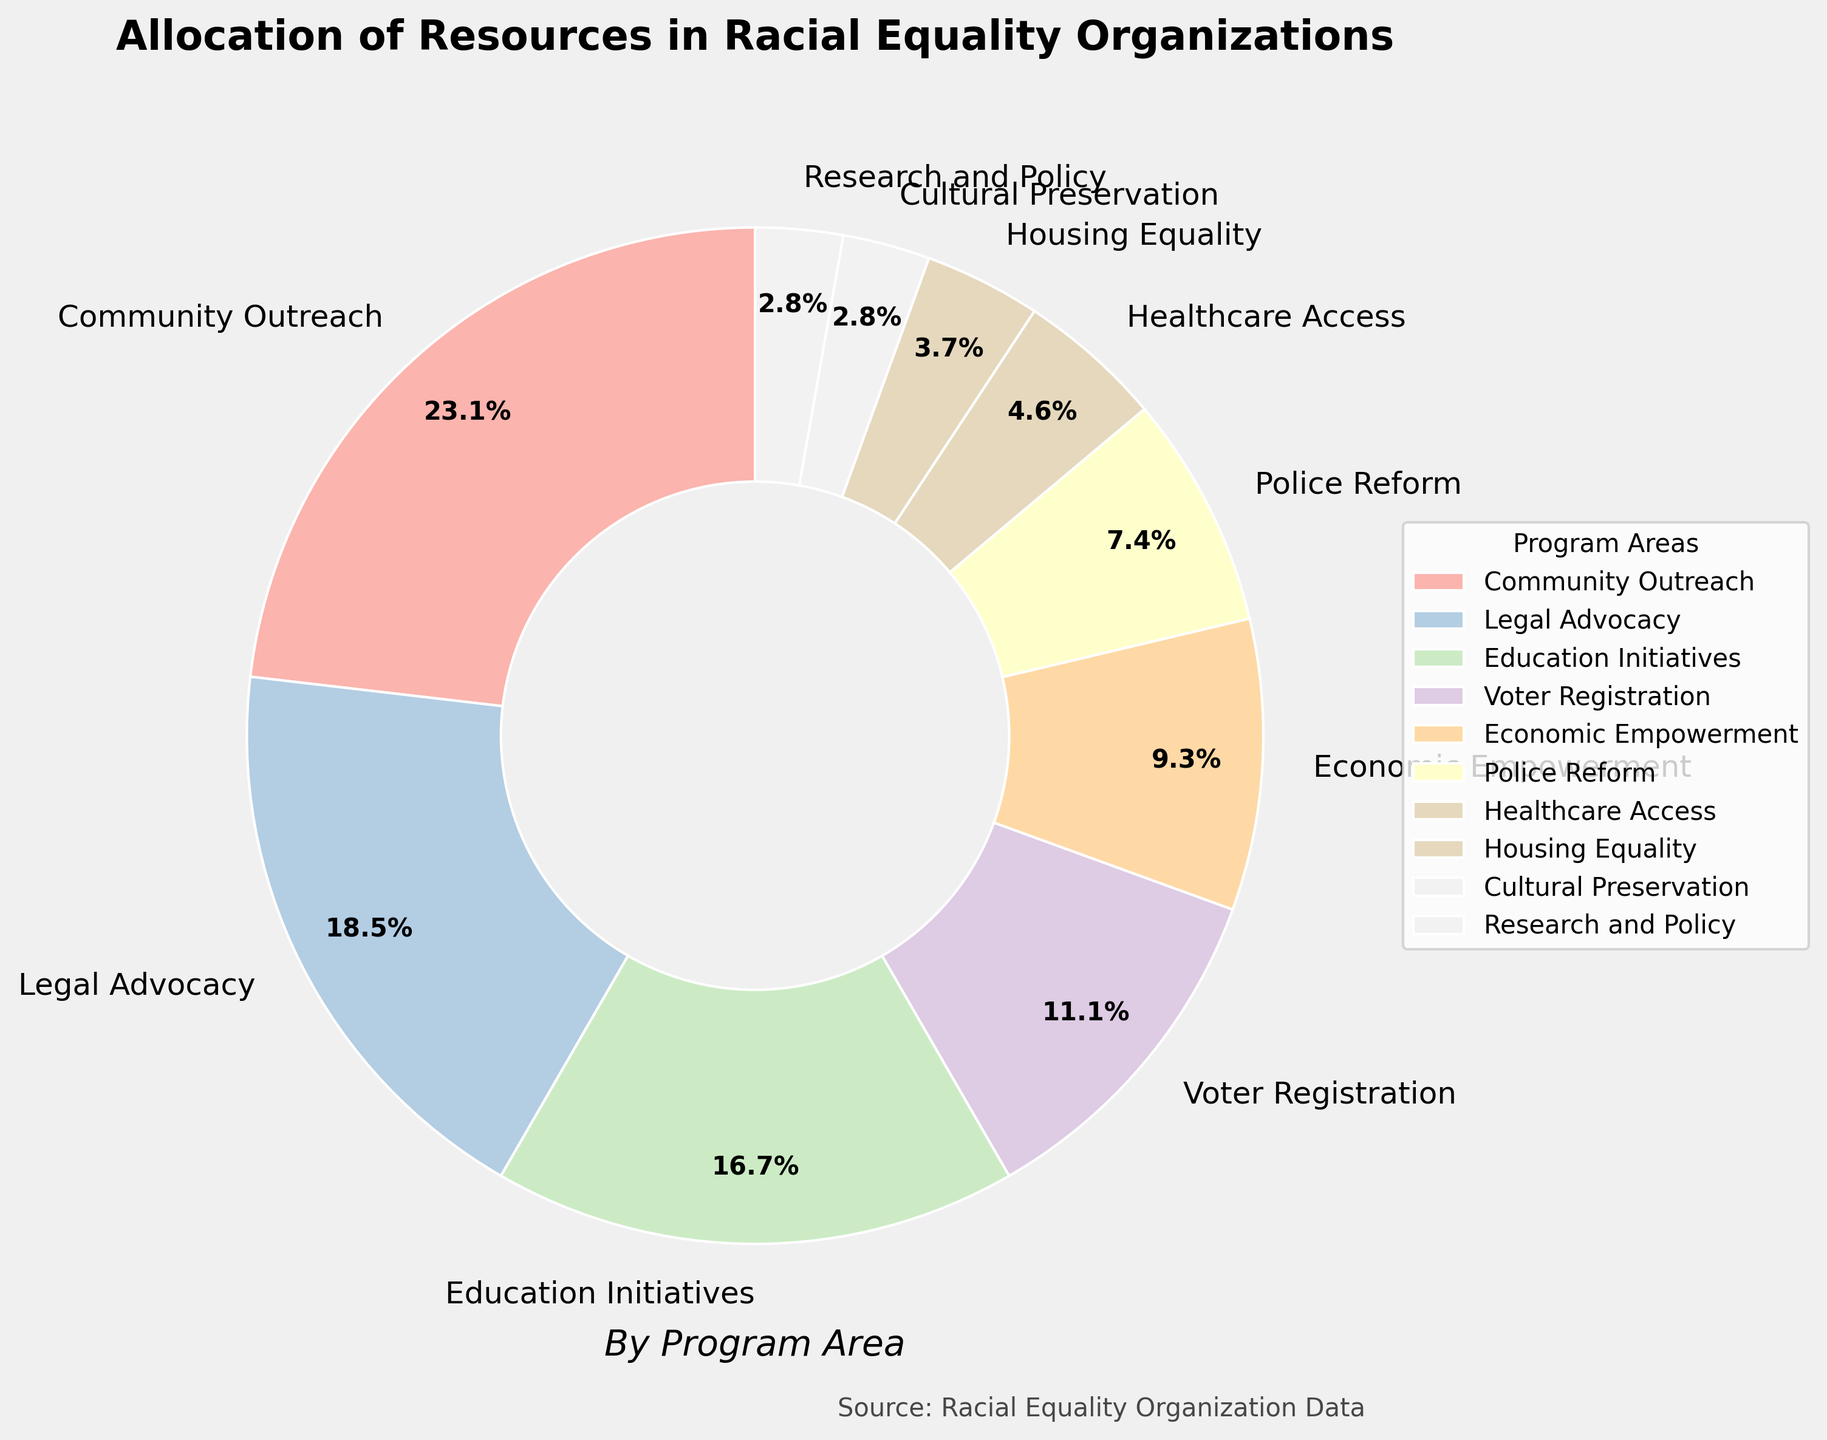What is the percentage allocation for Education Initiatives? According to the figure, the section labeled 'Education Initiatives' shows a percentage value.
Answer: 18% Which program area has the highest allocation of resources? The largest section in the pie chart corresponds to the 'Community Outreach' program area, indicating it has the highest allocation.
Answer: Community Outreach What is the combined percentage of resources allocated to Legal Advocacy and Police Reform? From the figure, Legal Advocacy is 20% and Police Reform is 8%. Adding these two: 20% + 8% = 28%
Answer: 28% How does the percentage allocation for Voter Registration compare to Housing Equality? The pie chart shows Voter Registration at 12% and Housing Equality at 4%. Therefore, Voter Registration has a higher allocation.
Answer: Voter Registration has a higher allocation What is the difference in percentage allocation between Community Outreach and Healthcare Access? Community Outreach has 25% and Healthcare Access has 5%. The difference is 25% - 5% = 20%.
Answer: 20% Are there any program areas with the same percentage allocation? The pie chart shows both Cultural Preservation and Research and Policy each have a 3% allocation.
Answer: Yes, Cultural Preservation and Research and Policy What is the total percentage of resources allocated to Economic Empowerment, Police Reform, and Healthcare Access combined? Economic Empowerment is 10%, Police Reform is 8%, and Healthcare Access is 5%. Adding these: 10% + 8% + 5% = 23%.
Answer: 23% How many program areas have an allocation of 10% or more? The pie chart shows Community Outreach (25%), Legal Advocacy (20%), Education Initiatives (18%), Voter Registration (12%), and Economic Empowerment (10%) each have 10% or more. There are 5 such program areas.
Answer: 5 Which program area has the smallest allocation of resources, and what is its percentage? The smallest section in the pie chart is for the 'Cultural Preservation' program area, representing a 3% allocation.
Answer: Cultural Preservation, 3% What's the average allocation percentage for the program areas? Adding the percentages: 25% + 20% + 18% + 12% + 10% + 8% + 5% + 4% + 3% + 3% = 108%. Dividing by the 10 program areas, 108% / 10 = 10.8%.
Answer: 10.8% 